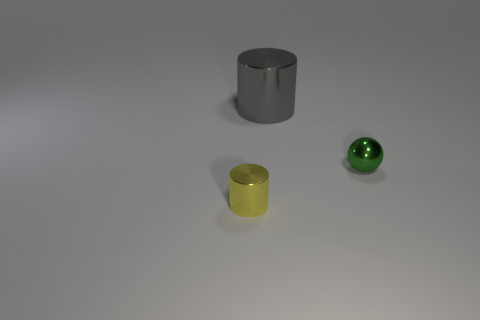What shape is the tiny metal object that is on the left side of the metallic object behind the ball?
Keep it short and to the point. Cylinder. Is the shape of the tiny thing that is to the left of the large gray cylinder the same as  the big gray object?
Your answer should be compact. Yes. What is the color of the object that is right of the large gray shiny cylinder?
Keep it short and to the point. Green. What number of cylinders are either big things or shiny things?
Provide a succinct answer. 2. What is the size of the metallic object that is behind the small object that is behind the yellow cylinder?
Give a very brief answer. Large. How many cylinders are behind the tiny metal cylinder?
Provide a short and direct response. 1. Are there fewer big gray objects than tiny purple shiny cylinders?
Offer a very short reply. No. There is a metal thing that is to the right of the tiny yellow metallic cylinder and on the left side of the small ball; what size is it?
Your answer should be very brief. Large. Are there fewer things behind the small metal cylinder than objects?
Your response must be concise. Yes. The green object that is the same material as the large gray cylinder is what shape?
Offer a terse response. Sphere. 